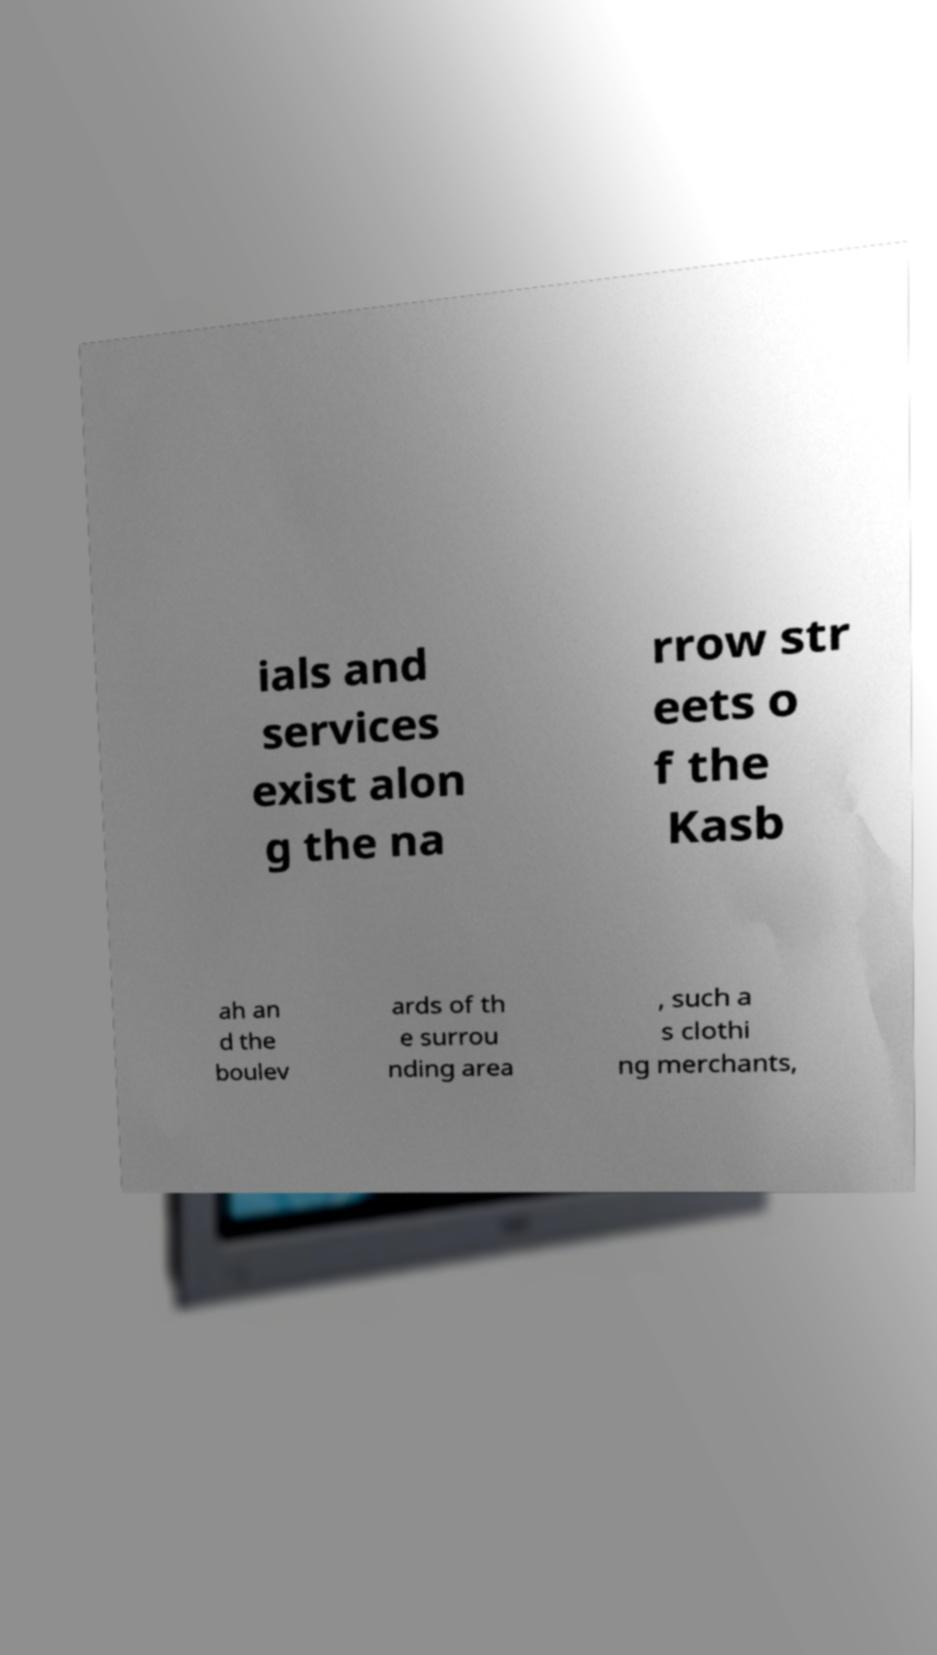Can you read and provide the text displayed in the image?This photo seems to have some interesting text. Can you extract and type it out for me? ials and services exist alon g the na rrow str eets o f the Kasb ah an d the boulev ards of th e surrou nding area , such a s clothi ng merchants, 